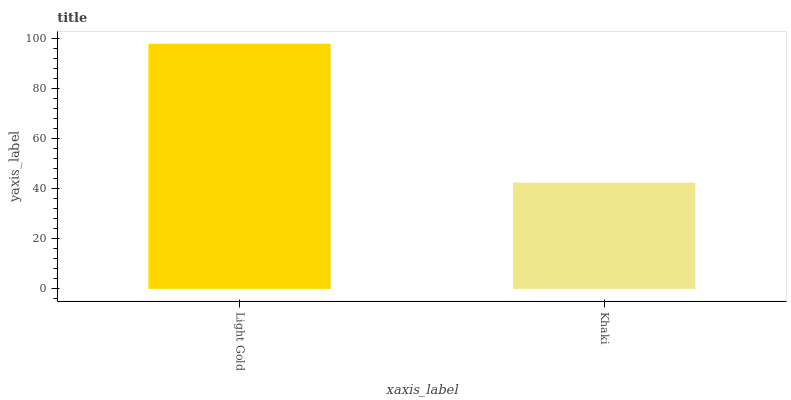Is Khaki the minimum?
Answer yes or no. Yes. Is Light Gold the maximum?
Answer yes or no. Yes. Is Khaki the maximum?
Answer yes or no. No. Is Light Gold greater than Khaki?
Answer yes or no. Yes. Is Khaki less than Light Gold?
Answer yes or no. Yes. Is Khaki greater than Light Gold?
Answer yes or no. No. Is Light Gold less than Khaki?
Answer yes or no. No. Is Light Gold the high median?
Answer yes or no. Yes. Is Khaki the low median?
Answer yes or no. Yes. Is Khaki the high median?
Answer yes or no. No. Is Light Gold the low median?
Answer yes or no. No. 